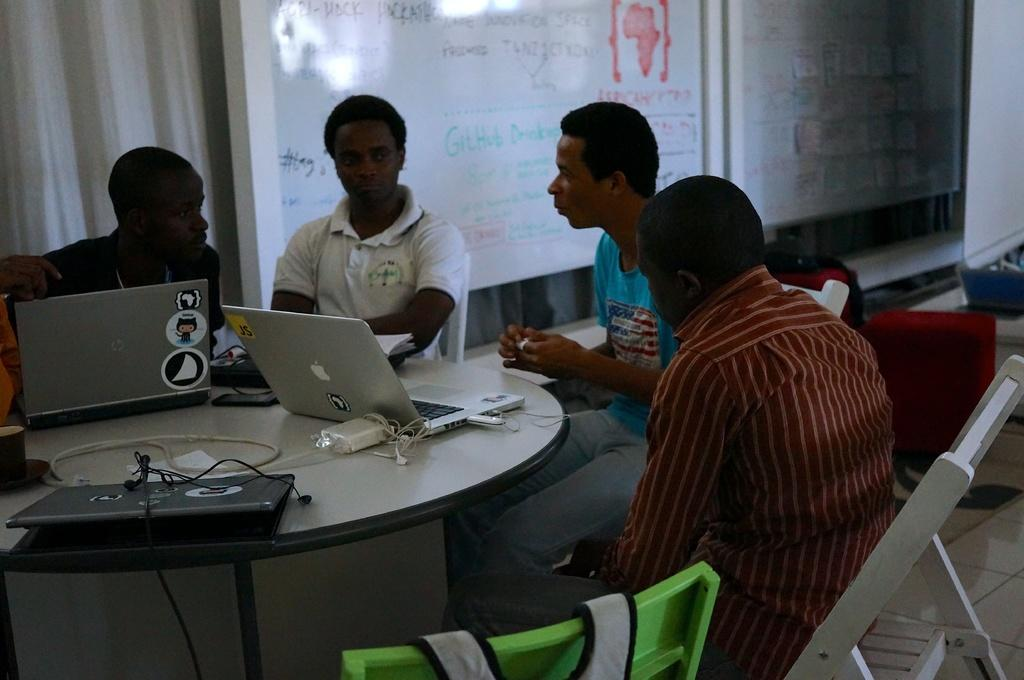How many people are in the image? There are four men in the image. What are the men doing in the image? The men are sitting on chairs and talking. What electronic device is present in the image? There is a laptop on a table in the image. What can be seen in the background of the image? There is a board and a curtain in the background of the image. What type of tramp can be seen jumping in the image? There is no tramp present in the image; it features four men sitting on chairs and talking. Is there a fire visible in the image? No, there is no fire visible in the image. 